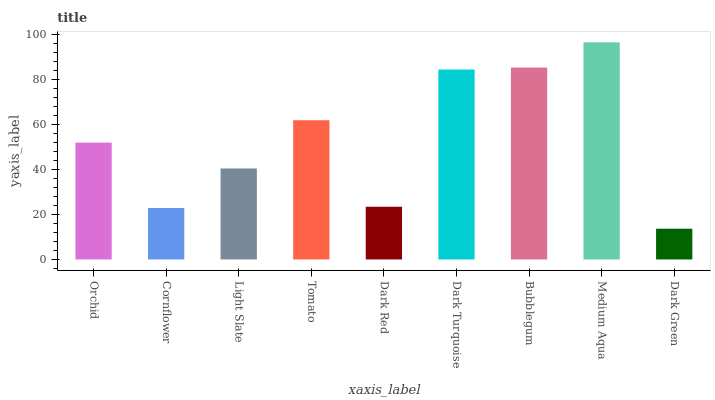Is Dark Green the minimum?
Answer yes or no. Yes. Is Medium Aqua the maximum?
Answer yes or no. Yes. Is Cornflower the minimum?
Answer yes or no. No. Is Cornflower the maximum?
Answer yes or no. No. Is Orchid greater than Cornflower?
Answer yes or no. Yes. Is Cornflower less than Orchid?
Answer yes or no. Yes. Is Cornflower greater than Orchid?
Answer yes or no. No. Is Orchid less than Cornflower?
Answer yes or no. No. Is Orchid the high median?
Answer yes or no. Yes. Is Orchid the low median?
Answer yes or no. Yes. Is Cornflower the high median?
Answer yes or no. No. Is Dark Turquoise the low median?
Answer yes or no. No. 